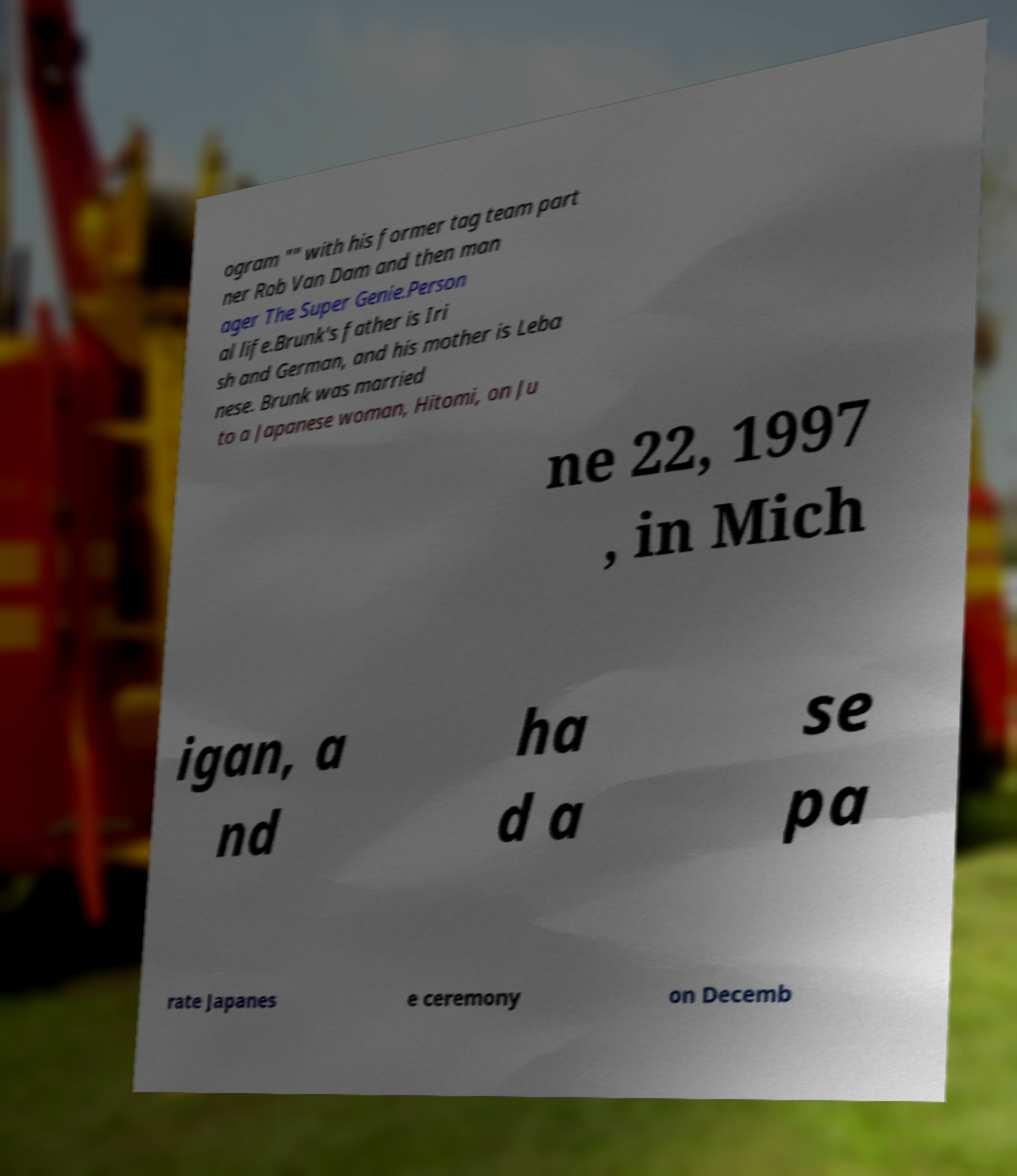What messages or text are displayed in this image? I need them in a readable, typed format. ogram "" with his former tag team part ner Rob Van Dam and then man ager The Super Genie.Person al life.Brunk's father is Iri sh and German, and his mother is Leba nese. Brunk was married to a Japanese woman, Hitomi, on Ju ne 22, 1997 , in Mich igan, a nd ha d a se pa rate Japanes e ceremony on Decemb 